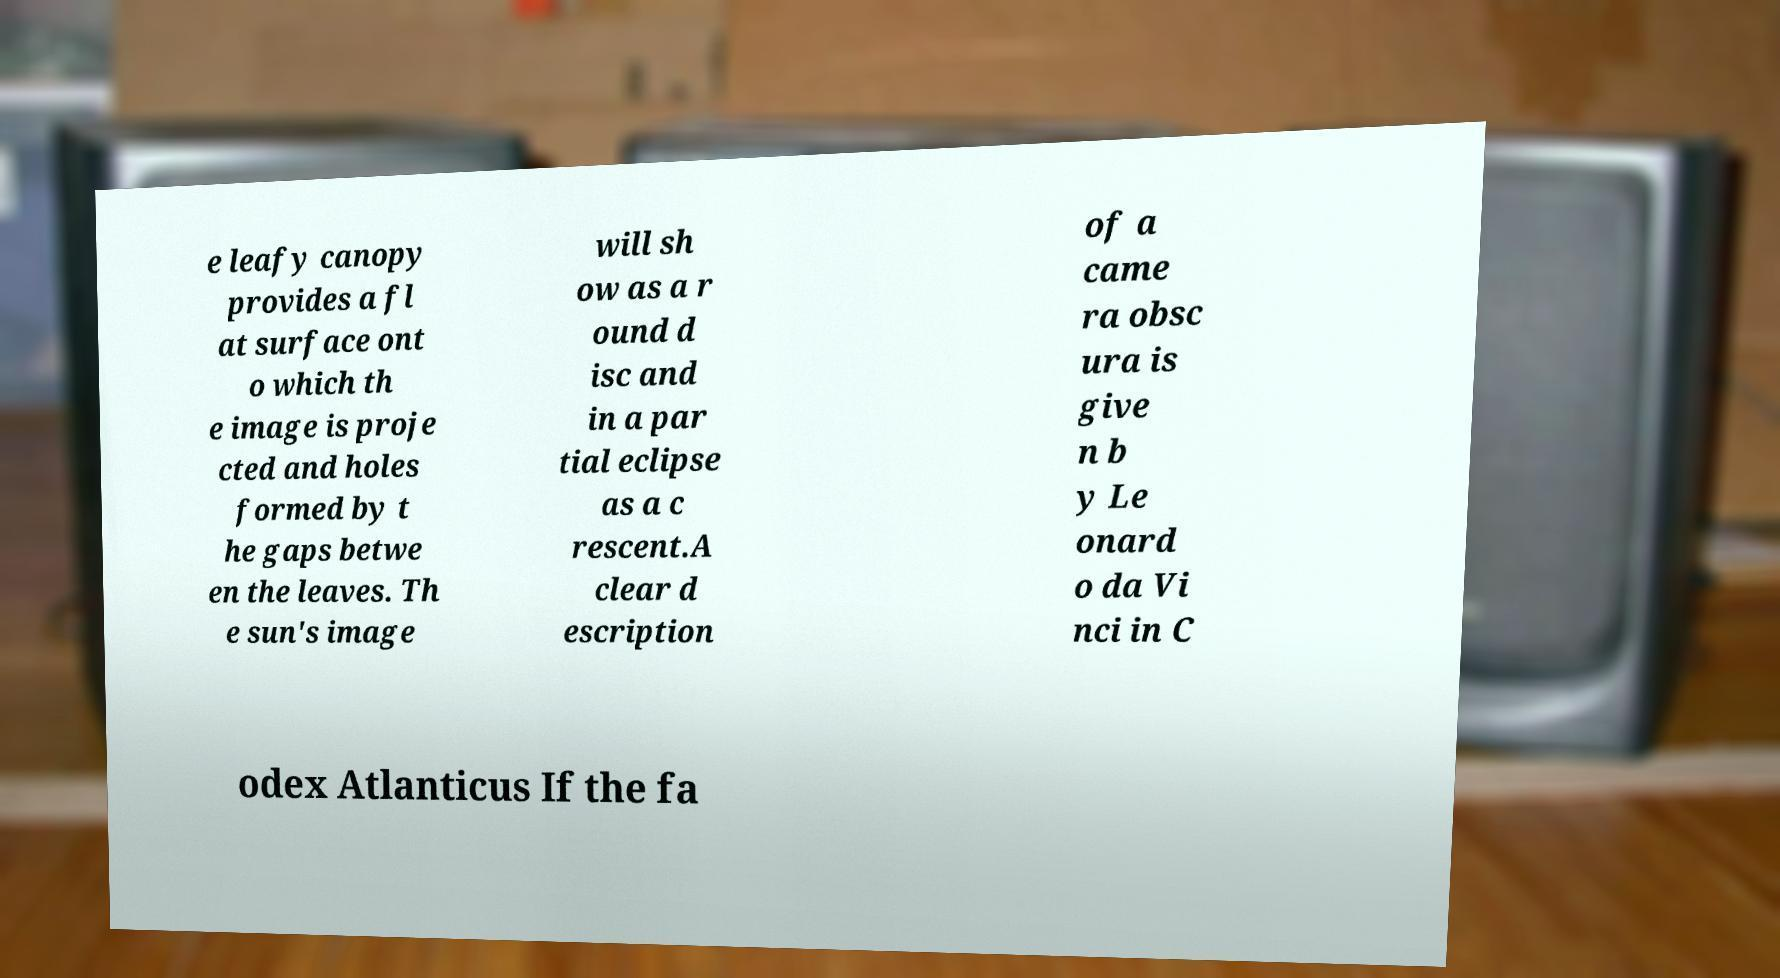I need the written content from this picture converted into text. Can you do that? e leafy canopy provides a fl at surface ont o which th e image is proje cted and holes formed by t he gaps betwe en the leaves. Th e sun's image will sh ow as a r ound d isc and in a par tial eclipse as a c rescent.A clear d escription of a came ra obsc ura is give n b y Le onard o da Vi nci in C odex Atlanticus If the fa 